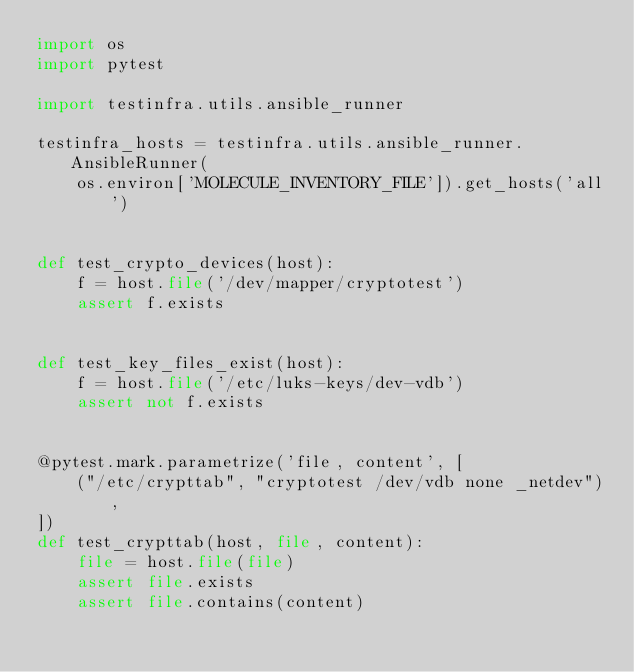<code> <loc_0><loc_0><loc_500><loc_500><_Python_>import os
import pytest

import testinfra.utils.ansible_runner

testinfra_hosts = testinfra.utils.ansible_runner.AnsibleRunner(
    os.environ['MOLECULE_INVENTORY_FILE']).get_hosts('all')


def test_crypto_devices(host):
    f = host.file('/dev/mapper/cryptotest')
    assert f.exists


def test_key_files_exist(host):
    f = host.file('/etc/luks-keys/dev-vdb')
    assert not f.exists


@pytest.mark.parametrize('file, content', [
    ("/etc/crypttab", "cryptotest /dev/vdb none _netdev"),
])
def test_crypttab(host, file, content):
    file = host.file(file)
    assert file.exists
    assert file.contains(content)
</code> 